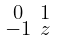<formula> <loc_0><loc_0><loc_500><loc_500>\begin{smallmatrix} 0 & 1 \\ - 1 & z \end{smallmatrix}</formula> 